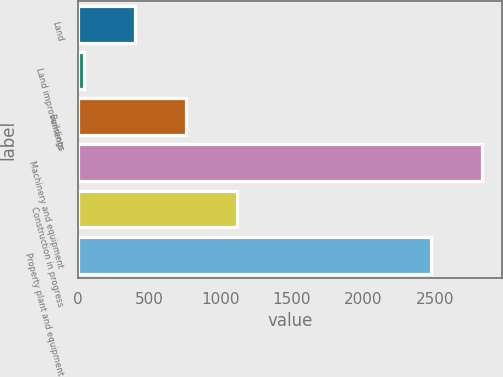Convert chart to OTSL. <chart><loc_0><loc_0><loc_500><loc_500><bar_chart><fcel>Land<fcel>Land improvements<fcel>Buildings<fcel>Machinery and equipment<fcel>Construction in progress<fcel>Property plant and equipment<nl><fcel>400.9<fcel>44<fcel>757.8<fcel>2828.9<fcel>1114.7<fcel>2472<nl></chart> 